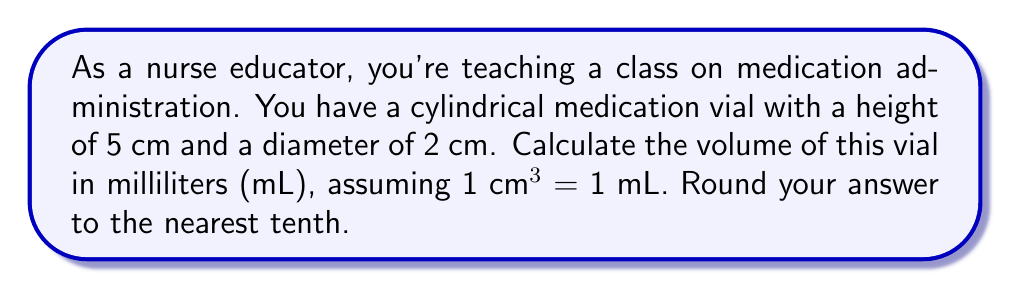Teach me how to tackle this problem. To calculate the volume of the cylindrical medication vial, we'll use the formula for the volume of a cylinder:

$$V = \pi r^2 h$$

Where:
$V$ = volume
$r$ = radius of the base
$h$ = height of the cylinder

Step 1: Determine the radius
The diameter is given as 2 cm, so the radius is half of that:
$r = 2 \text{ cm} \div 2 = 1 \text{ cm}$

Step 2: Apply the formula
$$V = \pi (1 \text{ cm})^2 (5 \text{ cm})$$

Step 3: Calculate
$$V = \pi \cdot 1 \text{ cm}^2 \cdot 5 \text{ cm}$$
$$V = 5\pi \text{ cm}^3$$

Step 4: Use $\pi \approx 3.14159$ to get a numerical value
$$V \approx 5 \cdot 3.14159 \text{ cm}^3$$
$$V \approx 15.70795 \text{ cm}^3$$

Step 5: Convert to mL (1 cm³ = 1 mL)
$$V \approx 15.70795 \text{ mL}$$

Step 6: Round to the nearest tenth
$$V \approx 15.7 \text{ mL}$$
Answer: 15.7 mL 